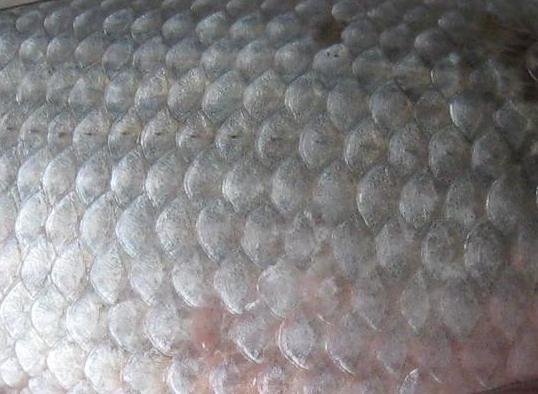How do the textures you described contribute to the survival or functionality of the creature from which they came? The textures observed in the image, including the smooth and glossy scales, serve significant biological functions. The smooth surface minimizes friction, allowing the creature to glide efficiently through water. The glossy appearance is often a result of a mucous layer that protects the scales from parasites and infections. The overlapping nature of the scales provides a robust armor that shields the underlying skin from physical injuries and bacterial invasions, enhancing the creature's survival in a challenging aquatic environment. 